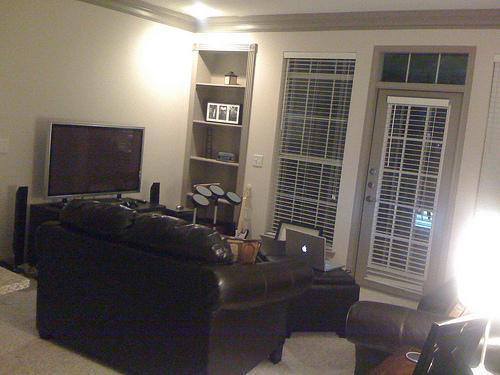How many televisions are there?
Give a very brief answer. 1. How many doors are there?
Give a very brief answer. 1. How many people are sitting on the sofa?
Give a very brief answer. 0. How many television sets are in the photo?
Give a very brief answer. 1. 